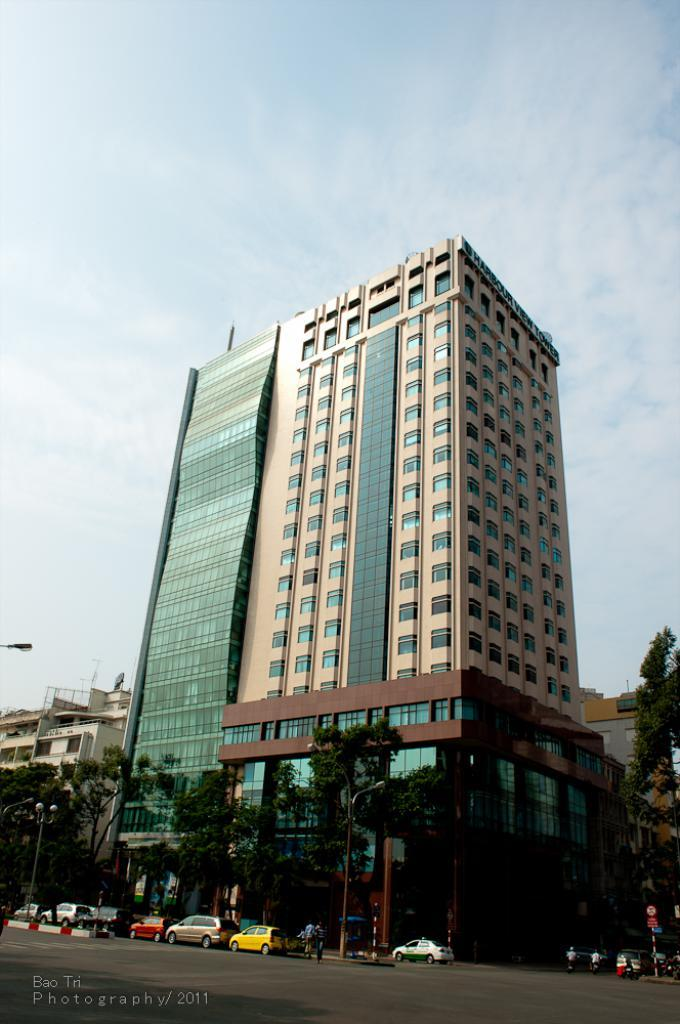What type of structures can be seen in the image? There are buildings in the image. What other natural elements are present in the image? There are trees in the image. What mode of transportation can be seen on the road in the image? There are cars and vehicles on the road in the image. Where is the text located in the image? The text is at the bottom left corner of the image. What is the weather condition in the image? The sky is cloudy in the image. How many cherries are hanging from the trees in the image? There are no cherries present in the image; it features buildings, trees, cars, text, and a cloudy sky. What type of curve can be seen in the image? There is no curve present in the image; it is a scene with buildings, trees, cars, text, and a cloudy sky. 